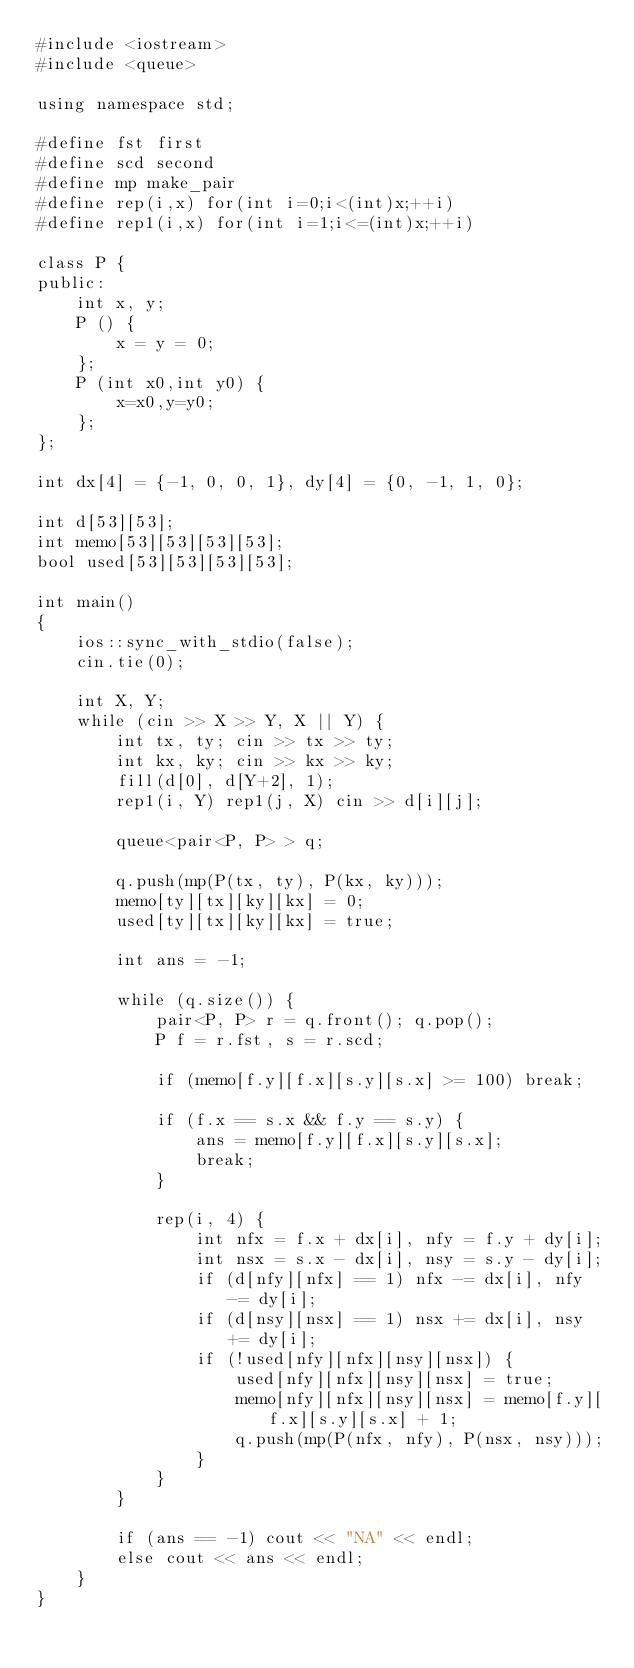<code> <loc_0><loc_0><loc_500><loc_500><_C++_>#include <iostream>
#include <queue>

using namespace std;

#define fst first
#define scd second
#define mp make_pair
#define rep(i,x) for(int i=0;i<(int)x;++i)
#define rep1(i,x) for(int i=1;i<=(int)x;++i)

class P {
public:
    int x, y;
    P () {
        x = y = 0;
    };
    P (int x0,int y0) {
        x=x0,y=y0;
    };
};

int dx[4] = {-1, 0, 0, 1}, dy[4] = {0, -1, 1, 0};

int d[53][53];
int memo[53][53][53][53];
bool used[53][53][53][53];

int main()
{
    ios::sync_with_stdio(false);
    cin.tie(0);

    int X, Y;
    while (cin >> X >> Y, X || Y) {
        int tx, ty; cin >> tx >> ty;
        int kx, ky; cin >> kx >> ky;
        fill(d[0], d[Y+2], 1);
        rep1(i, Y) rep1(j, X) cin >> d[i][j];

        queue<pair<P, P> > q;

        q.push(mp(P(tx, ty), P(kx, ky)));
        memo[ty][tx][ky][kx] = 0;
        used[ty][tx][ky][kx] = true;

        int ans = -1;

        while (q.size()) {
            pair<P, P> r = q.front(); q.pop();
            P f = r.fst, s = r.scd;

            if (memo[f.y][f.x][s.y][s.x] >= 100) break;

            if (f.x == s.x && f.y == s.y) {
                ans = memo[f.y][f.x][s.y][s.x];
                break;
            }

            rep(i, 4) {
                int nfx = f.x + dx[i], nfy = f.y + dy[i];
                int nsx = s.x - dx[i], nsy = s.y - dy[i];
                if (d[nfy][nfx] == 1) nfx -= dx[i], nfy -= dy[i];
                if (d[nsy][nsx] == 1) nsx += dx[i], nsy += dy[i];
                if (!used[nfy][nfx][nsy][nsx]) {
                    used[nfy][nfx][nsy][nsx] = true;
                    memo[nfy][nfx][nsy][nsx] = memo[f.y][f.x][s.y][s.x] + 1;
                    q.push(mp(P(nfx, nfy), P(nsx, nsy)));
                }
            }
        }

        if (ans == -1) cout << "NA" << endl;
        else cout << ans << endl;
    }
}</code> 